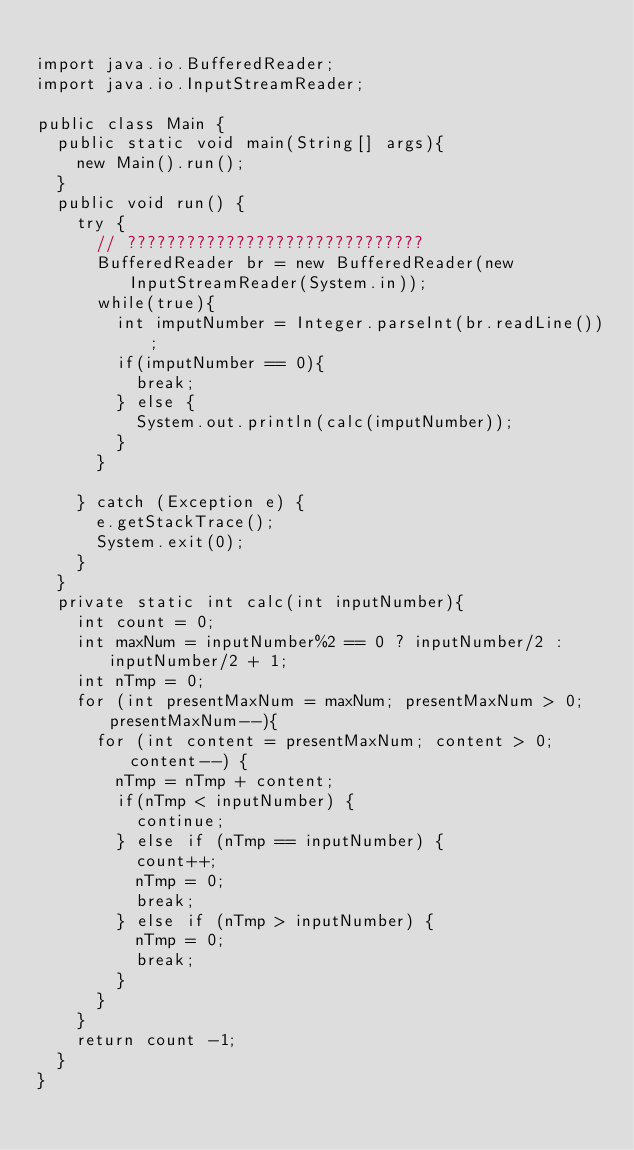Convert code to text. <code><loc_0><loc_0><loc_500><loc_500><_Java_>
import java.io.BufferedReader;
import java.io.InputStreamReader;

public class Main {
	public static void main(String[] args){
		new Main().run();
	}
	public void run() {
		try {
			// ??????????????????????????????
			BufferedReader br = new BufferedReader(new InputStreamReader(System.in));
			while(true){
				int imputNumber = Integer.parseInt(br.readLine());
				if(imputNumber == 0){
					break;
				} else {
					System.out.println(calc(imputNumber));
				}
			}

		} catch (Exception e) {
			e.getStackTrace();
			System.exit(0);
		}
	}
	private static int calc(int inputNumber){
		int count = 0;
		int maxNum = inputNumber%2 == 0 ? inputNumber/2 : inputNumber/2 + 1;
		int nTmp = 0;
		for (int presentMaxNum = maxNum; presentMaxNum > 0; presentMaxNum--){
			for (int content = presentMaxNum; content > 0; content--) {
				nTmp = nTmp + content;
				if(nTmp < inputNumber) {
					continue;
				} else if (nTmp == inputNumber) {
					count++;
					nTmp = 0;
					break;
				} else if (nTmp > inputNumber) {
					nTmp = 0;
					break;
				}
			}
		}
		return count -1;
	}
}</code> 